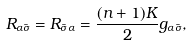<formula> <loc_0><loc_0><loc_500><loc_500>R _ { \alpha \bar { \sigma } } = R _ { \bar { \sigma } \alpha } = \frac { ( n + 1 ) K } { 2 } g _ { \alpha \bar { \sigma } } ,</formula> 